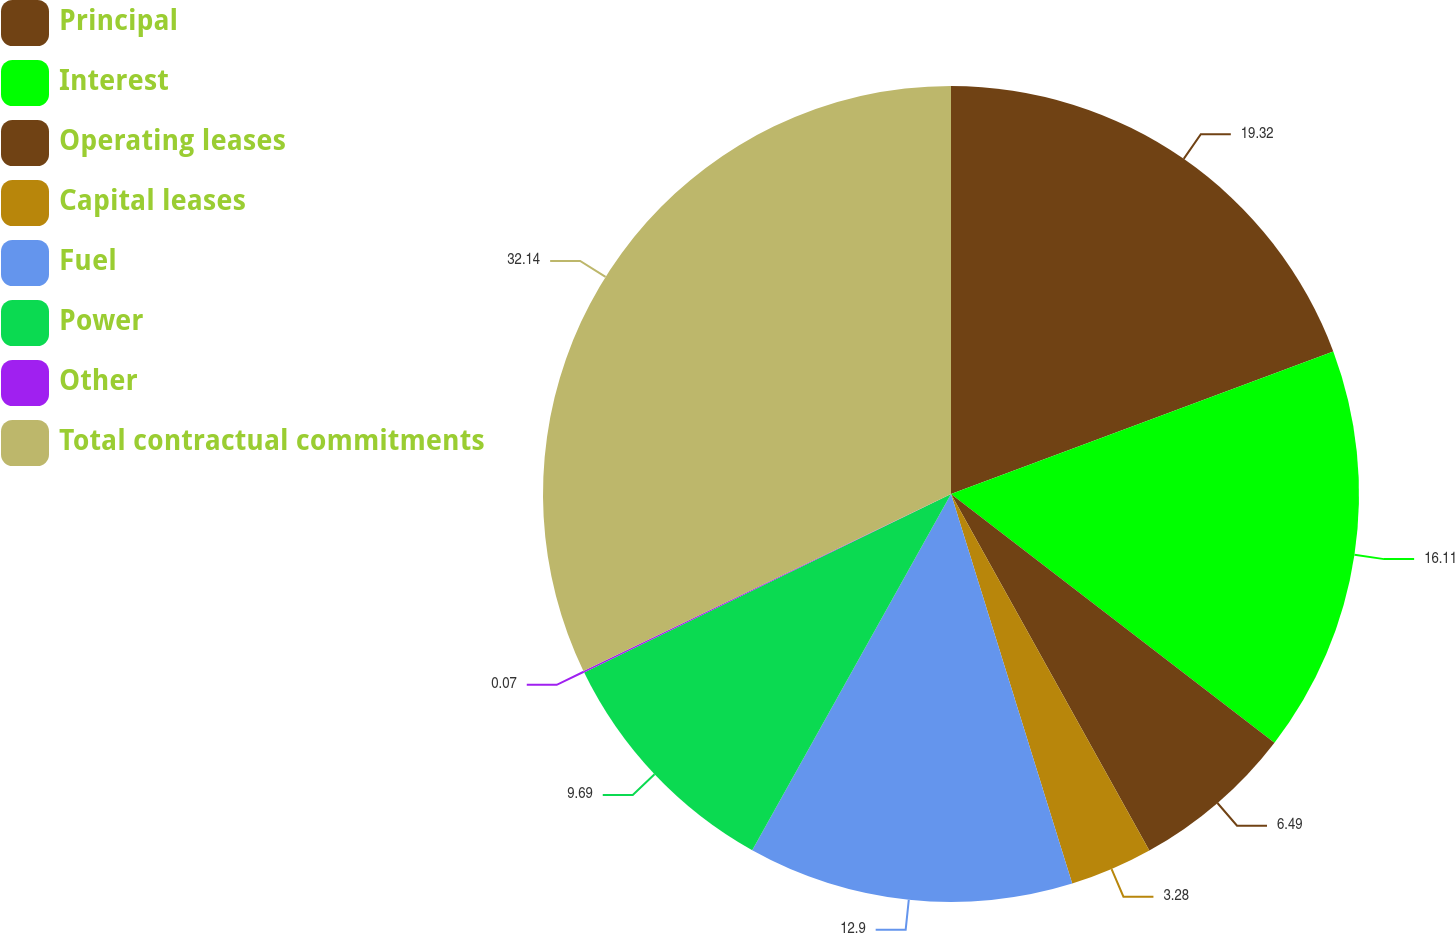<chart> <loc_0><loc_0><loc_500><loc_500><pie_chart><fcel>Principal<fcel>Interest<fcel>Operating leases<fcel>Capital leases<fcel>Fuel<fcel>Power<fcel>Other<fcel>Total contractual commitments<nl><fcel>19.32%<fcel>16.11%<fcel>6.49%<fcel>3.28%<fcel>12.9%<fcel>9.69%<fcel>0.07%<fcel>32.14%<nl></chart> 